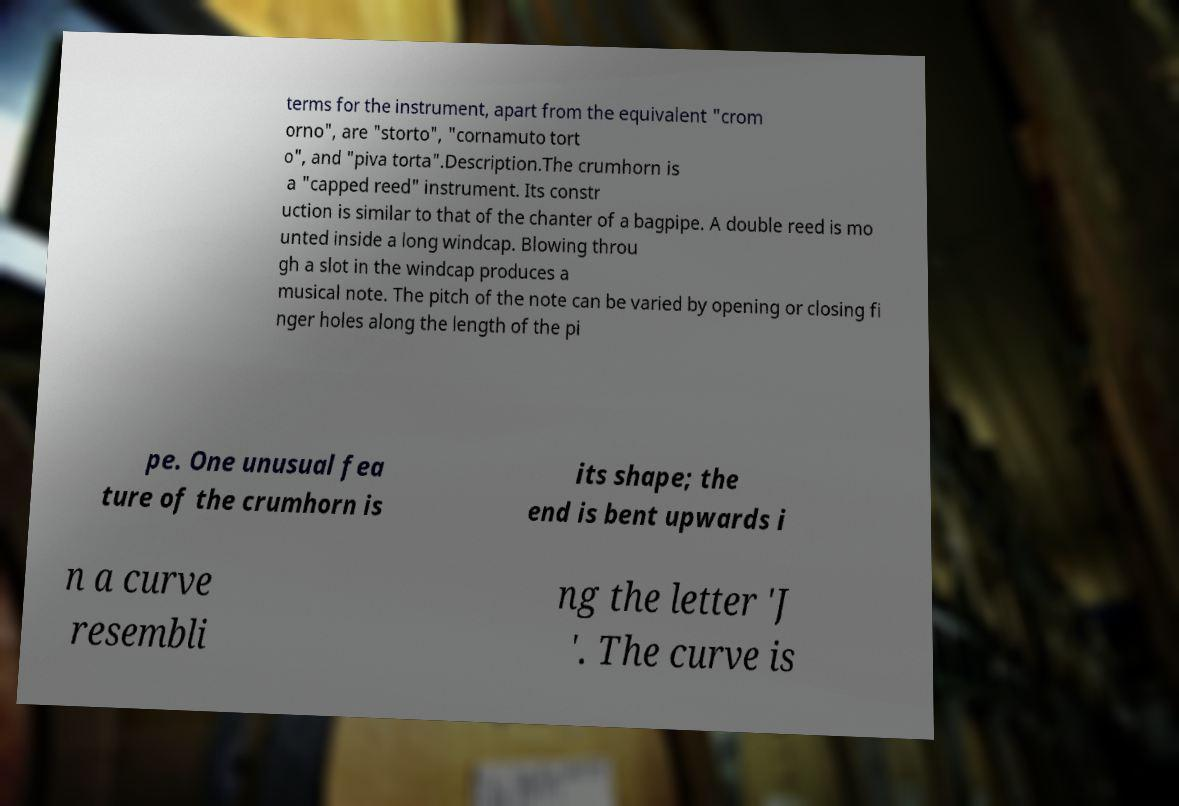I need the written content from this picture converted into text. Can you do that? terms for the instrument, apart from the equivalent "crom orno", are "storto", "cornamuto tort o", and "piva torta".Description.The crumhorn is a "capped reed" instrument. Its constr uction is similar to that of the chanter of a bagpipe. A double reed is mo unted inside a long windcap. Blowing throu gh a slot in the windcap produces a musical note. The pitch of the note can be varied by opening or closing fi nger holes along the length of the pi pe. One unusual fea ture of the crumhorn is its shape; the end is bent upwards i n a curve resembli ng the letter 'J '. The curve is 